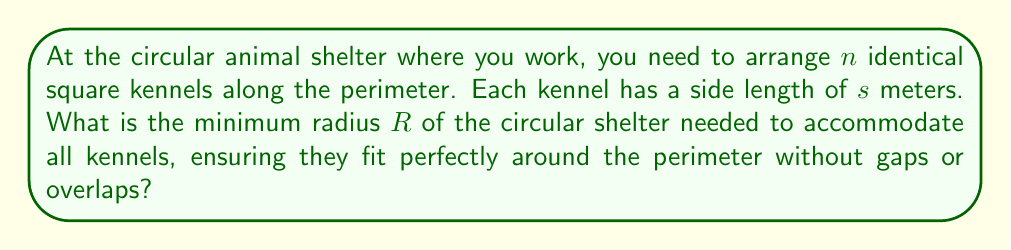Teach me how to tackle this problem. To solve this problem, we need to follow these steps:

1) First, we need to calculate the total length of all kennels when placed side by side:
   
   Total length = $n \cdot s$

2) This total length will form the circumference of the circular shelter. We know that the circumference of a circle is given by $2\pi R$, where $R$ is the radius.

3) Therefore, we can set up the equation:

   $2\pi R = n \cdot s$

4) Solving for $R$:

   $$R = \frac{n \cdot s}{2\pi}$$

5) However, this assumes the kennels can bend to fit the curve of the circle, which they can't. We need to inscribe the kennels in the circle.

6) The kennels will form a regular $n$-gon inscribed in the circle. The radius of the circumscribed circle (our shelter) is related to the side length of the inscribed regular polygon by:

   $$R = \frac{s}{2\sin(\frac{\pi}{n})}$$

7) This formula gives us the minimum radius needed to fit $n$ square kennels of side length $s$ around the perimeter of a circular shelter.

[asy]
import geometry;

int n = 8;
real s = 1;
real R = s / (2*sin(pi/n));

pair center = (0,0);
path circle = Circle(center, R);
draw(circle);

for (int i = 0; i < n; ++i) {
  pair p1 = R * dir(360*i/n);
  pair p2 = R * dir(360*(i+1)/n);
  draw(p1--p2);
}

label("R", (R/2, 0), E);
label("s", (R*cos(pi/n), R*sin(pi/n)/2), NE);

[/asy]
Answer: The minimum radius $R$ of the circular shelter needed to accommodate $n$ square kennels of side length $s$ is:

$$R = \frac{s}{2\sin(\frac{\pi}{n})}$$ 